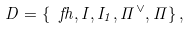Convert formula to latex. <formula><loc_0><loc_0><loc_500><loc_500>\ D = \{ \ f h , I , I _ { 1 } , \Pi ^ { \vee } , \Pi \} \, ,</formula> 